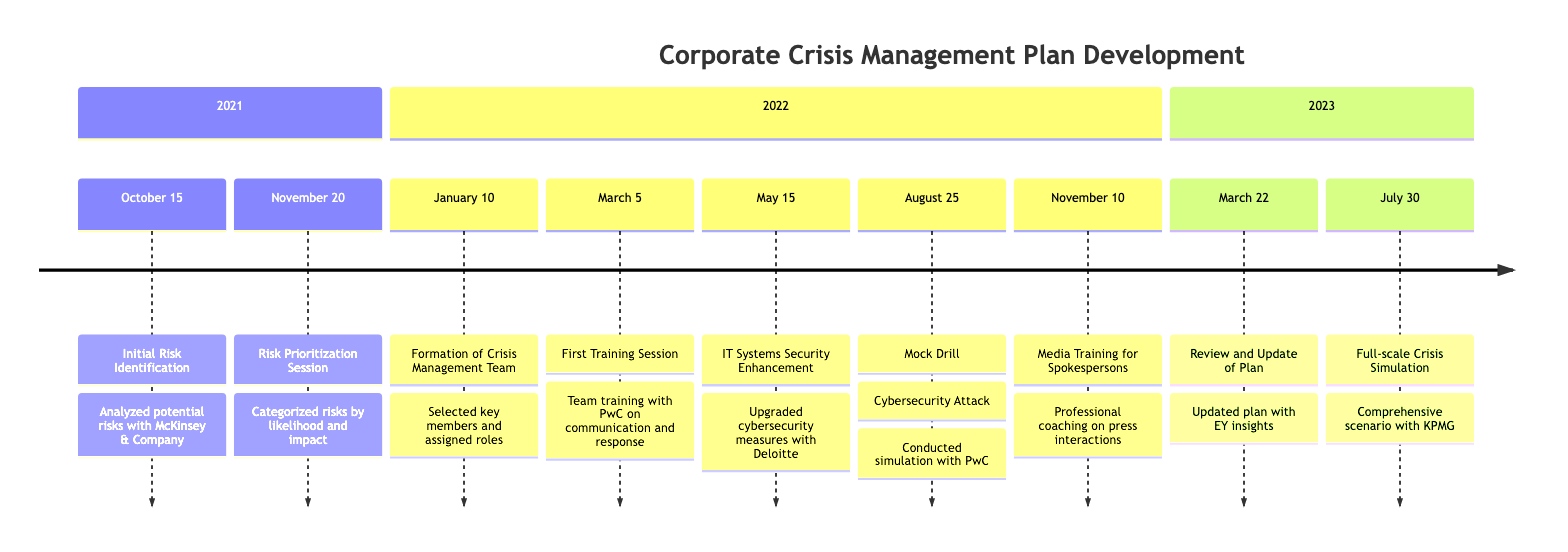What was the initial event in the timeline? The first event listed is the "Initial Risk Identification" on October 15, 2021, which identifies various potential risks.
Answer: Initial Risk Identification How many training sessions were conducted for the Crisis Management Team? There are two training sessions noted: the "First Training Session for Crisis Management Team" on March 5, 2022, and "Media Training for Spokespersons" on November 10, 2022.
Answer: 2 What company facilitated the mock drill on August 25, 2022? The mock drill conducted on this date was facilitated by PwC, as indicated in the timeline description.
Answer: PwC What was a major focus of the risk prioritization session conducted on November 20, 2021? The major focus of the risk prioritization session was to categorize identified risks based on their likelihood and impact.
Answer: Categorization of risks Which company was involved in the full-scale crisis simulation on July 30, 2023? The full-scale crisis simulation was executed in partnership with KPMG, as stated in the timeline.
Answer: KPMG What was the date of the review and update of the crisis management plan? The review and update occurred on March 22, 2023, as noted on the timeline.
Answer: March 22, 2023 What type of simulation was conducted on August 25, 2022? The simulation conducted on this date was specifically a "cybersecurity attack," meant to test the team's response capabilities.
Answer: Cybersecurity attack Which company was consulted for IT systems security enhancement on May 15, 2022? Deloitte was consulted for enhancing IT systems security to upgrade cybersecurity measures.
Answer: Deloitte 